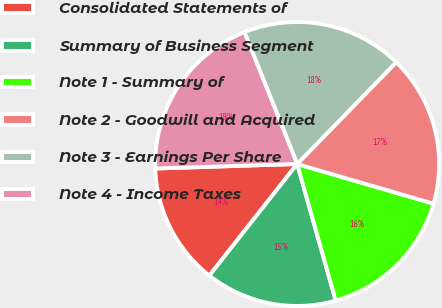Convert chart to OTSL. <chart><loc_0><loc_0><loc_500><loc_500><pie_chart><fcel>Consolidated Statements of<fcel>Summary of Business Segment<fcel>Note 1 - Summary of<fcel>Note 2 - Goodwill and Acquired<fcel>Note 3 - Earnings Per Share<fcel>Note 4 - Income Taxes<nl><fcel>13.88%<fcel>14.99%<fcel>16.11%<fcel>17.22%<fcel>18.34%<fcel>19.45%<nl></chart> 